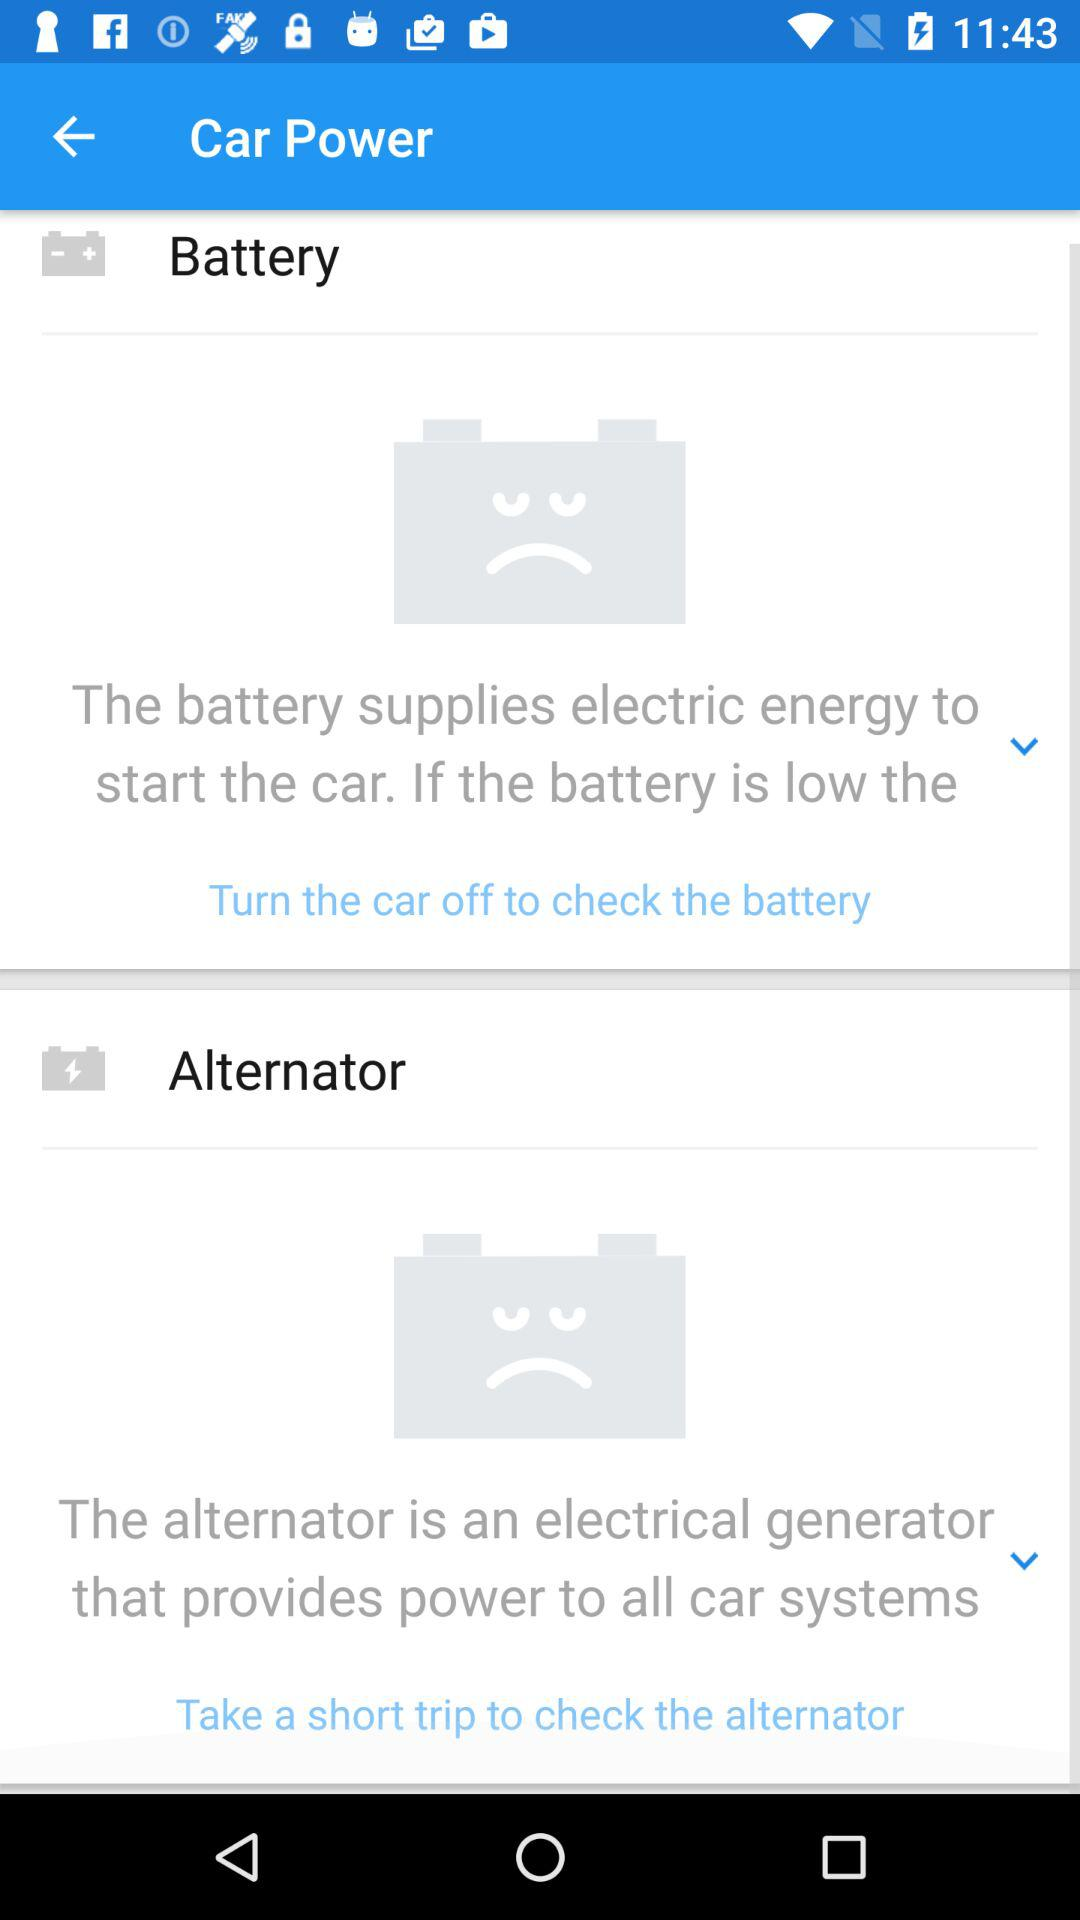How to check the battery? To check the battery, turn the car off. 